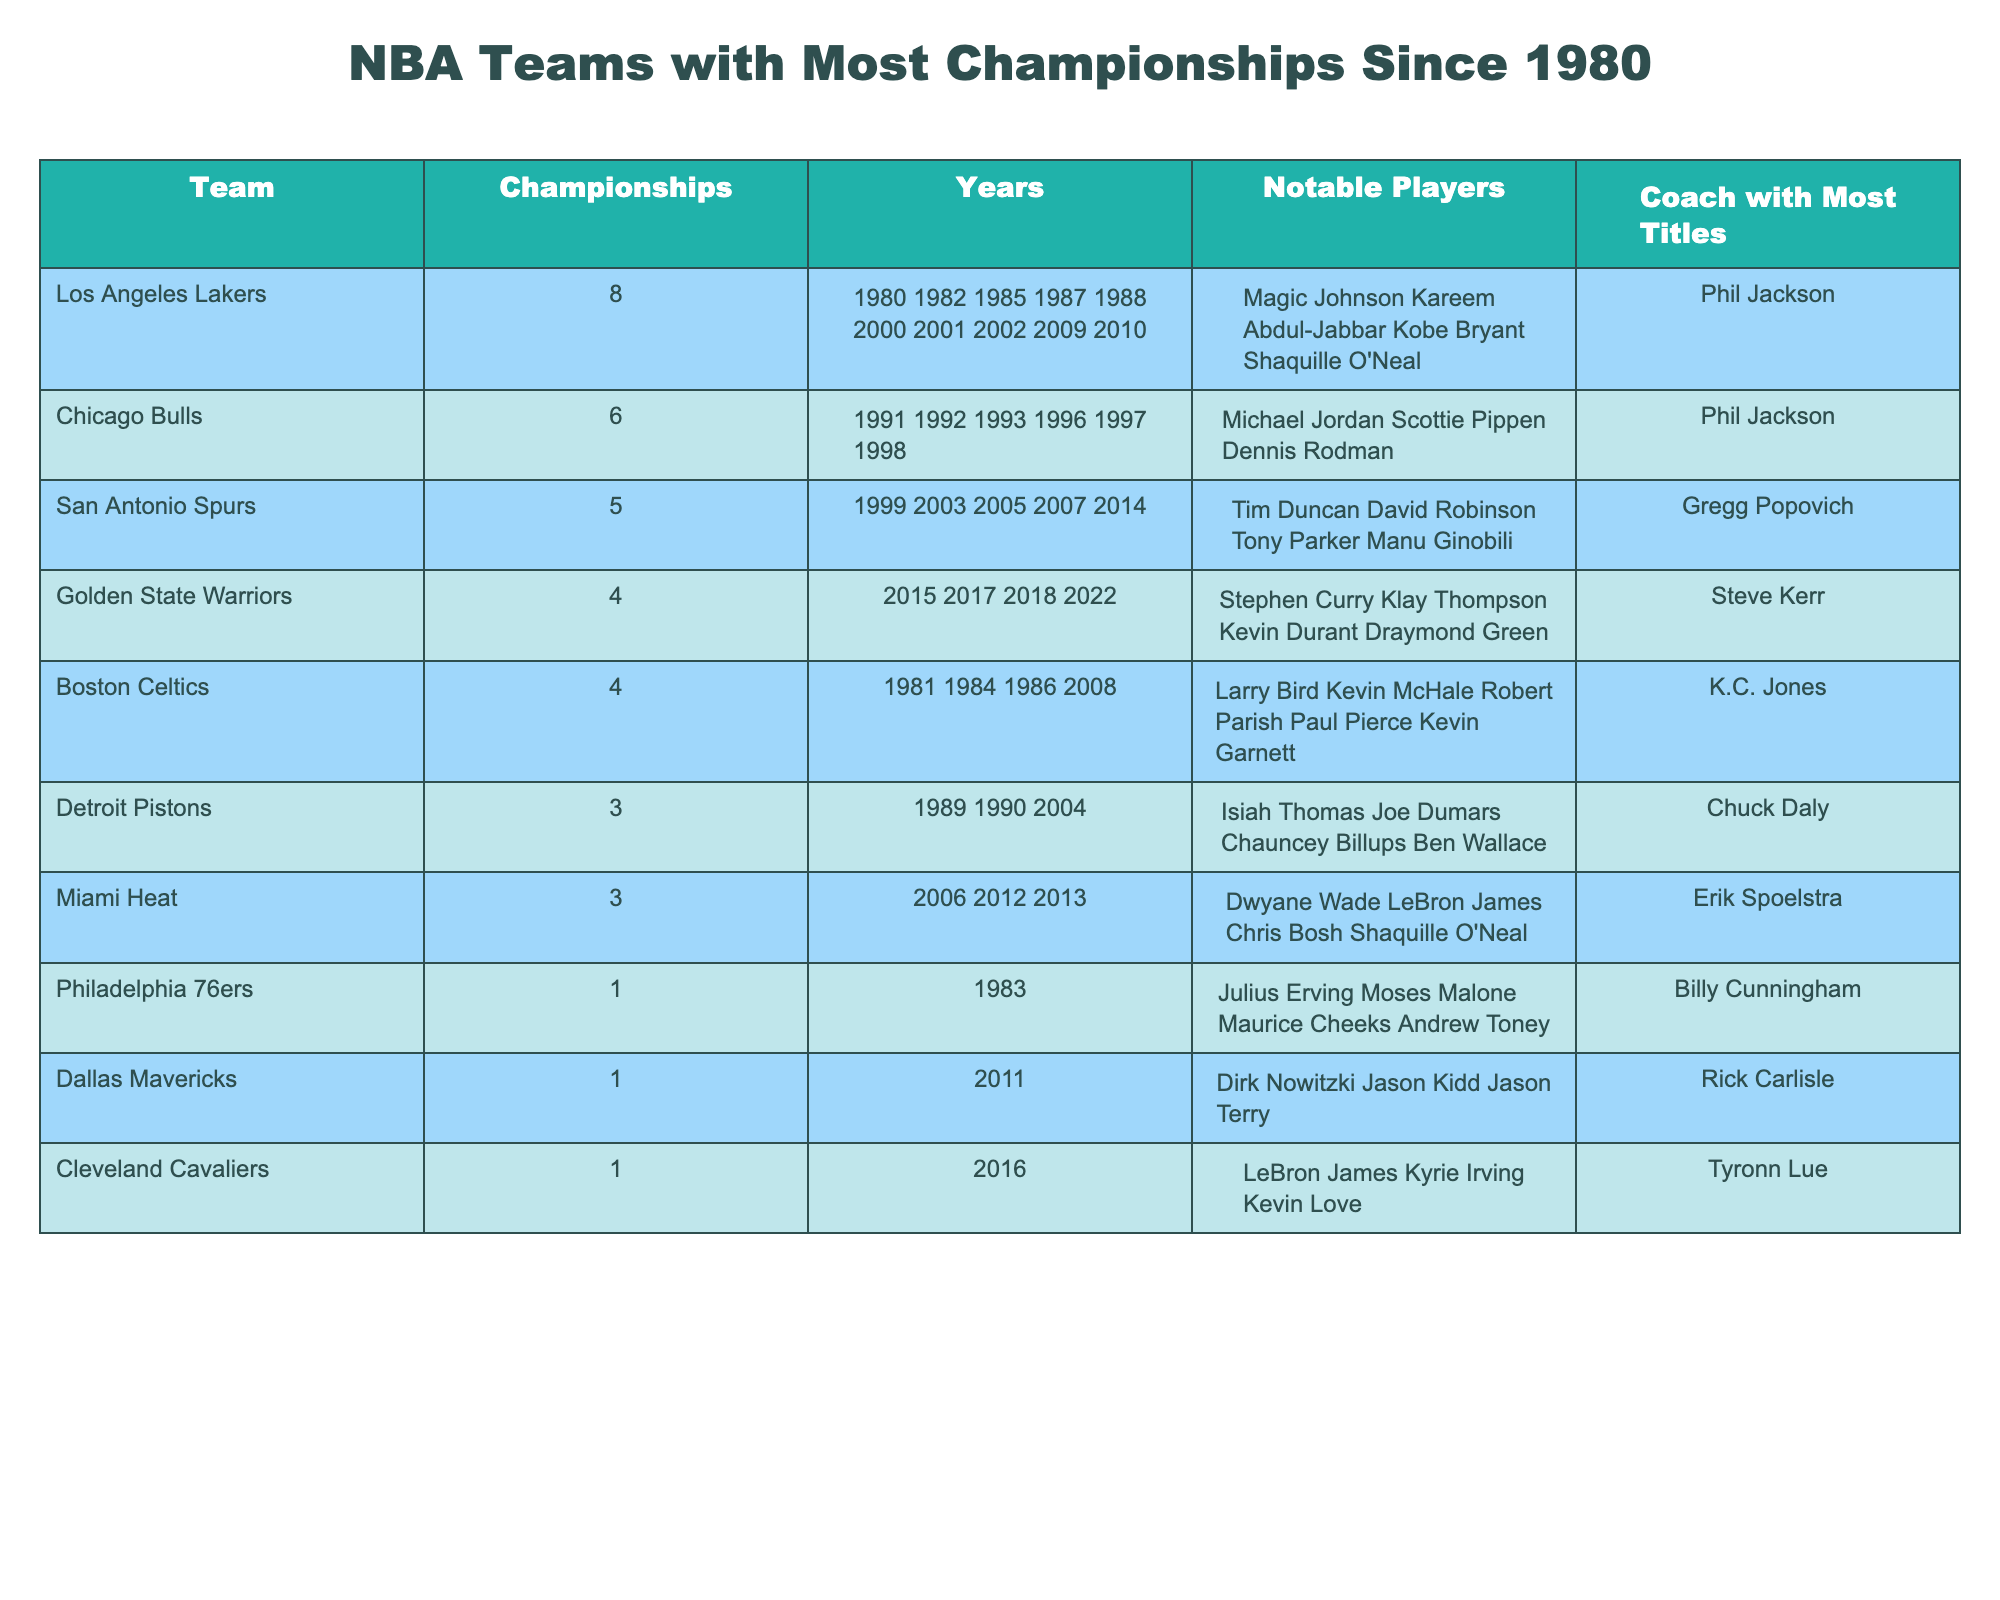What team has the most championships since 1980? The table lists the teams along with the number of championships won since 1980. The Los Angeles Lakers have 8 championships, which is the highest number on the table.
Answer: Los Angeles Lakers How many championships did the Chicago Bulls win? By looking at the table, the Chicago Bulls won a total of 6 championships, as stated in the "Championships" column next to their name.
Answer: 6 Which coach has the most titles in this list? The table provides the coach associated with each team. Phil Jackson has the most titles, coaching both the Los Angeles Lakers and the Chicago Bulls.
Answer: Phil Jackson What years did the San Antonio Spurs win their championships? The table includes a "Years" column with specific years for each team's championships. The San Antonio Spurs won in 1999, 2003, 2005, 2007, and 2014.
Answer: 1999, 2003, 2005, 2007, 2014 Which teams won exactly three championships? Referring to the "Championships" column, the teams with exactly 3 championships are the Detroit Pistons and Miami Heat.
Answer: Detroit Pistons, Miami Heat If you sum up the championships won by the Boston Celtics and the Golden State Warriors, what is the total? To find the total, add the number of championships from each team: Boston Celtics (4) + Golden State Warriors (4) = 8.
Answer: 8 Is it true that the Philadelphia 76ers have more championships than the Dallas Mavericks? The table shows the Philadelphia 76ers have 1 championship, while the Dallas Mavericks also have 1 championship. Therefore, the statement is false.
Answer: No What is the average number of championships won by the teams listed? To find the average, sum the championships (8 + 6 + 5 + 4 + 4 + 3 + 3 + 1 + 1 + 1 = 36) and divide by the number of teams (10). The average is 36/10 = 3.6.
Answer: 3.6 Which player is noted as a notable player for the Miami Heat? The "Notable Players" column for the Miami Heat lists Dwyane Wade, LeBron James, Chris Bosh, and Shaquille O'Neal. Any of these can be an answer.
Answer: Dwyane Wade How many teams have won at least four championships since 1980? By examining the "Championships" column, you find the teams with 4 or more championships: Los Angeles Lakers (8), Chicago Bulls (6), San Antonio Spurs (5), and Boston Celtics (4). That makes a total of 4 teams.
Answer: 4 